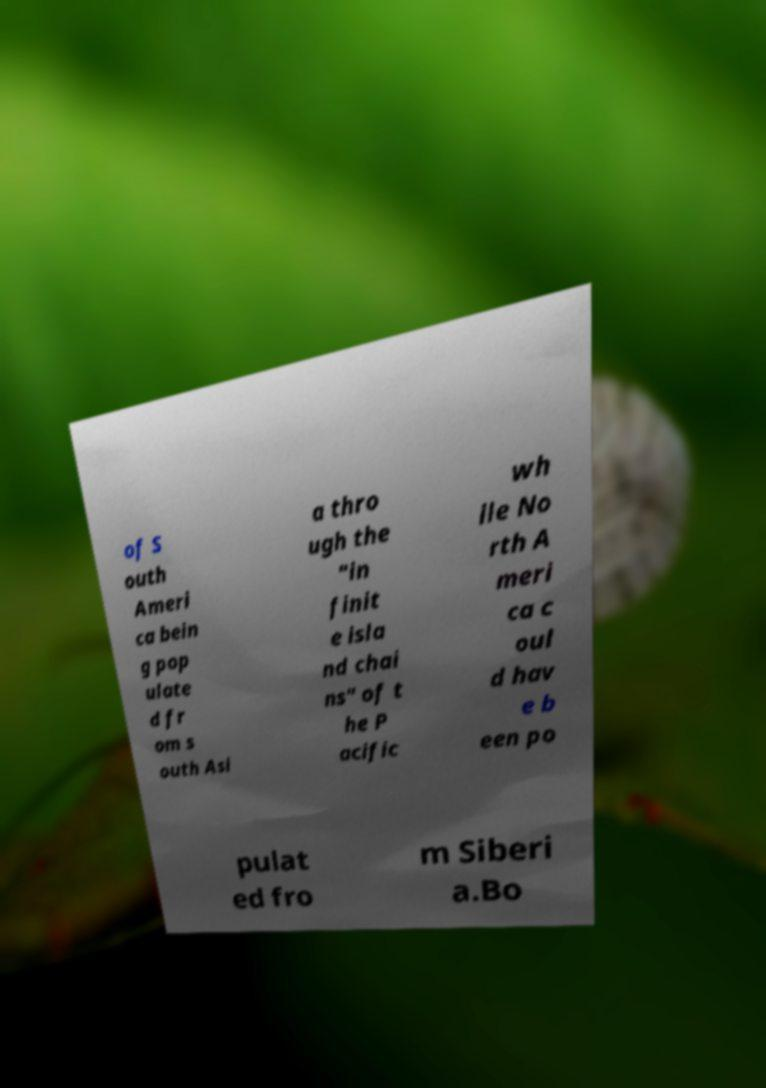Please identify and transcribe the text found in this image. of S outh Ameri ca bein g pop ulate d fr om s outh Asi a thro ugh the "in finit e isla nd chai ns" of t he P acific wh ile No rth A meri ca c oul d hav e b een po pulat ed fro m Siberi a.Bo 